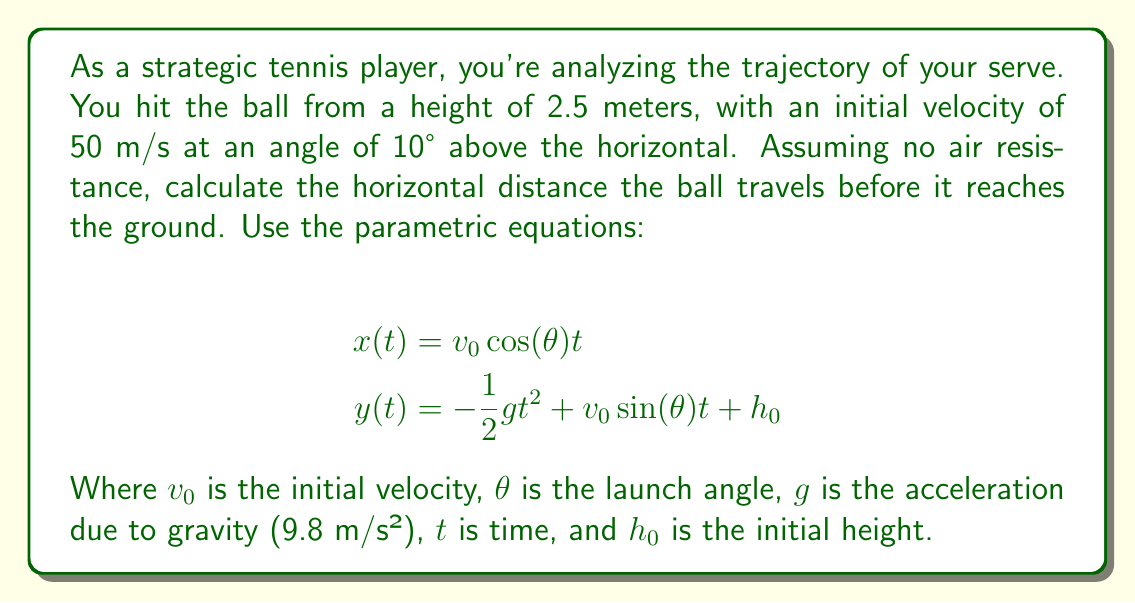Teach me how to tackle this problem. To solve this problem, we'll follow these steps:

1) First, we need to find the time when the ball hits the ground. This occurs when $y(t) = 0$.

2) We'll use the given equation for $y(t)$:

   $$y(t) = -\frac{1}{2}gt^2 + v_0 \sin(\theta) t + h_0$$

3) Substitute the known values:
   $g = 9.8$ m/s², $v_0 = 50$ m/s, $\theta = 10°$, $h_0 = 2.5$ m

   $$0 = -4.9t^2 + 50 \sin(10°) t + 2.5$$

4) Simplify:
   $$0 = -4.9t^2 + 8.682t + 2.5$$

5) This is a quadratic equation. We can solve it using the quadratic formula:

   $$t = \frac{-b \pm \sqrt{b^2 - 4ac}}{2a}$$

   Where $a = -4.9$, $b = 8.682$, and $c = 2.5$

6) Solving this gives us two solutions: $t \approx -0.358$ and $t \approx 1.930$

   We discard the negative solution as time cannot be negative.

7) Now that we know the time, we can use the equation for $x(t)$ to find the horizontal distance:

   $$x(t) = v_0 \cos(\theta) t$$

8) Substitute the values:
   $$x(1.930) = 50 \cos(10°) * 1.930$$

9) Calculate:
   $$x \approx 95.1 \text{ meters}$$
Answer: The horizontal distance the ball travels before hitting the ground is approximately 95.1 meters. 